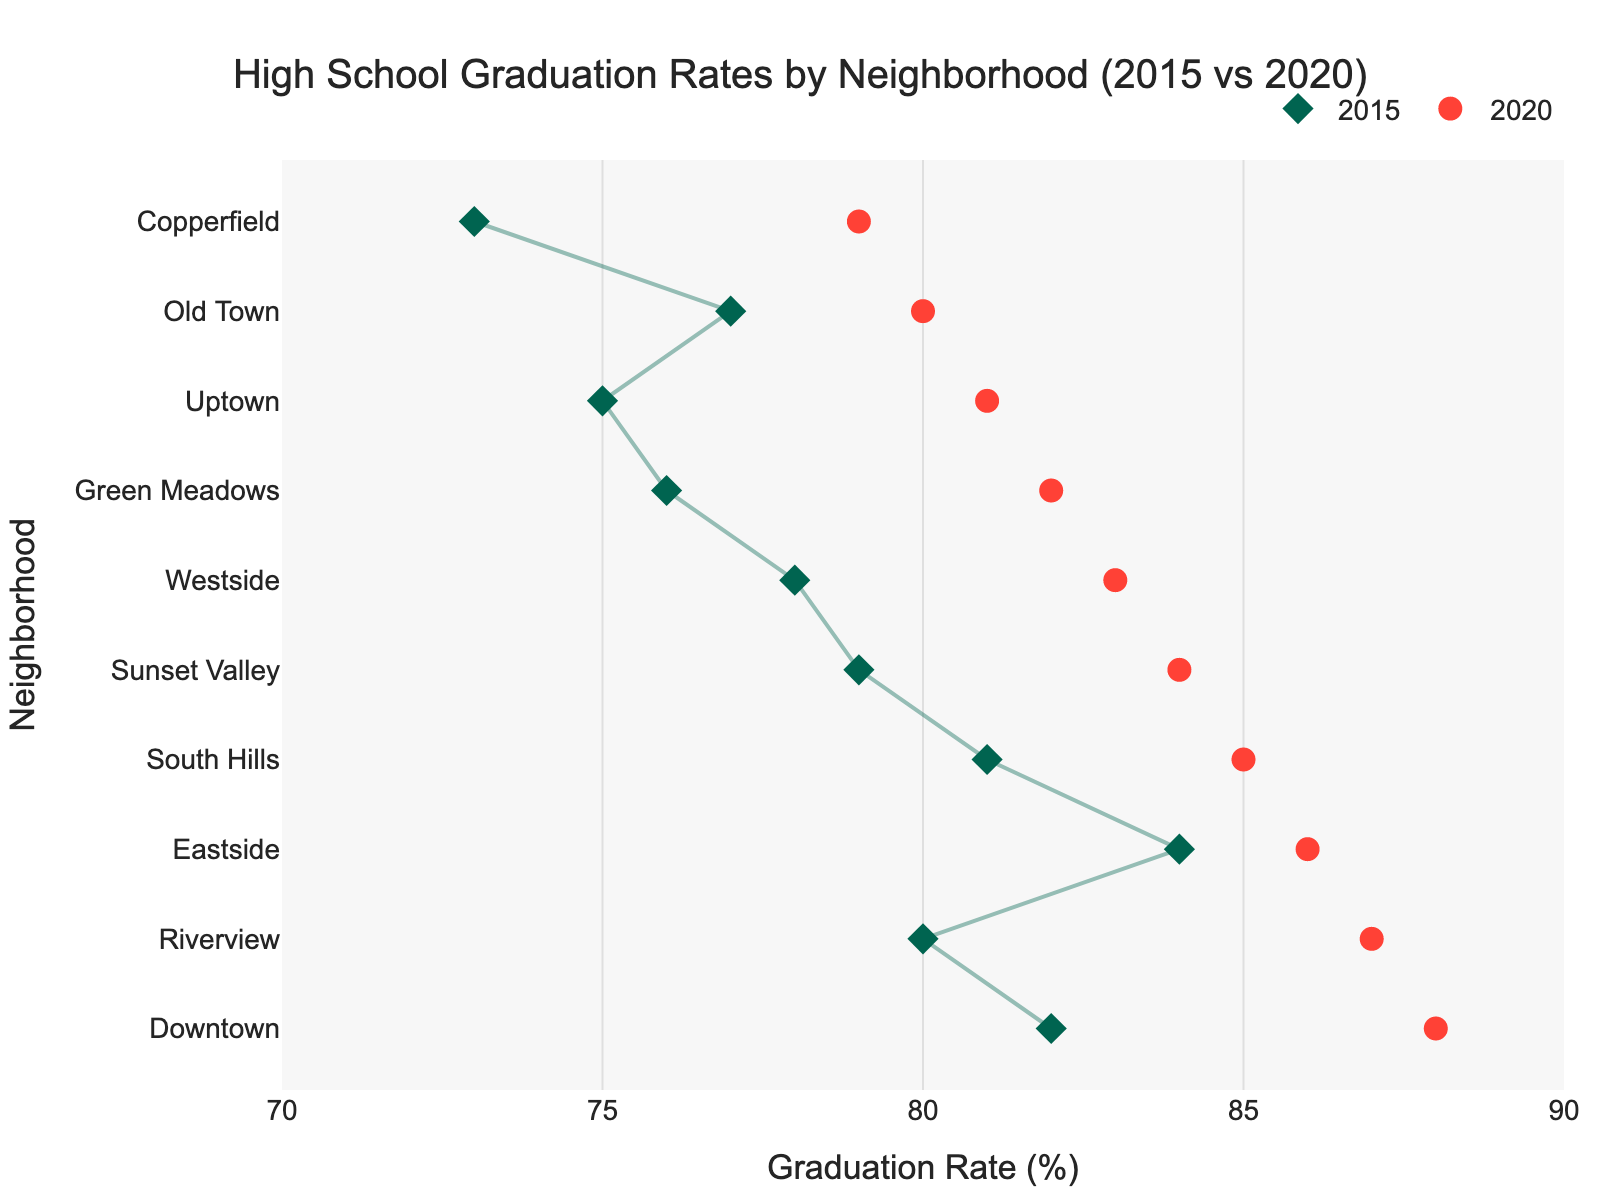what is the title of the figure? The title of the figure is located at the top and center, written in larger font size, making it visually prominent and clearly descriptive of what the plot represents. It states that the data is about high school graduation rates by neighborhood for the years 2015 and 2020.
Answer: High School Graduation Rates by Neighborhood (2015 vs 2020) Which neighborhood had the highest graduation rate in 2020? By observing the topmost point on the plot's y-axis (which represents neighborhoods sorted by 2020 graduation rates in descending order), you can see that "Downtown" had the highest graduation rate in 2020.
Answer: Downtown What's the graduation rate change for Uptown from 2015 to 2020? To determine the change, identify Uptown's 2015 graduation rate (75) and its 2020 rate (81). Subtract the 2015 rate from the 2020 rate: 81 - 75 = 6.
Answer: 6% What is the color of the markers representing the 2020 graduation rates? The 2020 graduation rates markers are distinctly colored to differentiate from the 2015 markers. By looking at the legend or the plot markers themselves, the color is clearly red.
Answer: Red How many neighborhoods had a graduation rate below 80% in 2015? Examine the x-axis and locate the markers for 2015. Count how many neighborhoods have their 2015 markers below the 80% graduation rate line: “Uptown,” “Old Town,” “Copperfield,” and “Green Meadows”, are below 80%.
Answer: 4 Which neighborhood showed the smallest increase in graduation rates from 2015 to 2020? Calculate the difference for each neighborhood between 2015 and 2020 graduation rates. Eastside shows an increase from 84 to 86, which is the smallest increment of 2.
Answer: Eastside What is the average graduation rate in 2020 across all the neighborhoods? Add up all the 2020 graduation rates and divide by the number of neighborhoods. The rates are (88, 81, 83, 86, 80, 85, 79, 87, 82, 84). Their sum is 835, divided by 10 (the number of neighborhoods), the average is 83.5.
Answer: 83.5% Which neighborhoods had graduation rates greater than 85% in 2020? Identify the neighborhoods with 2020 graduation rates above 85 by looking at the x-axis markers for 2020: “Downtown,” “Riverview,” “South Hills,” and “Eastside”.
Answer: Downtown, Riverview, South Hills, Eastside Which neighborhood has the largest gap between its 2015 and 2020 graduation rates? Calculate the difference for each neighborhood between 2015 and 2020. Riverview shows a gap of 7 points, increasing from 80 to 87, the largest observed difference.
Answer: Riverview What is the overall trend in graduation rates from 2015 to 2020 across all neighborhoods? Observe the markers' general direction for each neighborhood. All neighborhoods show an increase in graduation rates, indicating a general upward trend from 2015 to 2020.
Answer: Upward trend 